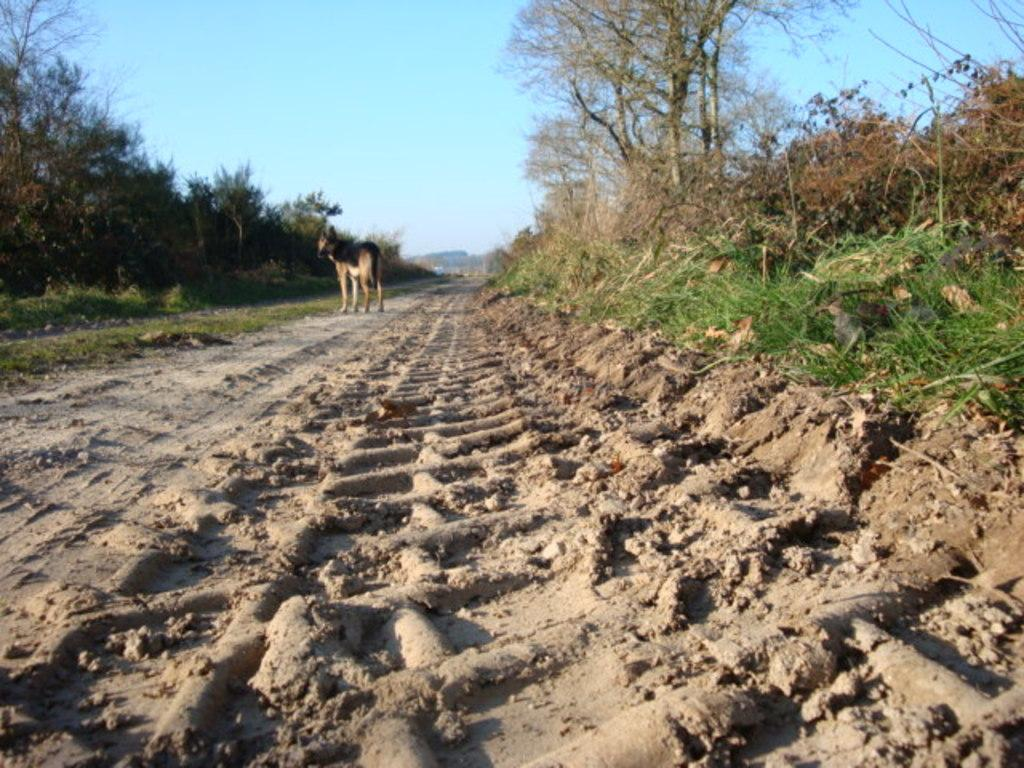What type of animal can be seen on the ground in the image? There is an animal on the ground in the image. What type of vegetation is present in the image? There is grass, plants, and trees in the image. What can be seen in the background of the image? The sky is visible in the background of the image. What class is the animal attending in the image? The image does not depict the animal attending a class, so it cannot be determined from the image. 